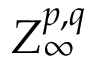Convert formula to latex. <formula><loc_0><loc_0><loc_500><loc_500>Z _ { \infty } ^ { p , q }</formula> 